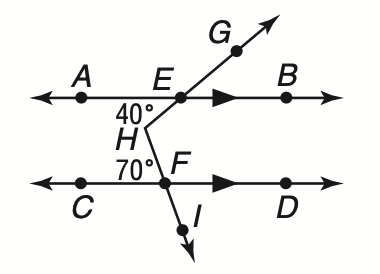Question: What is the measure of \angle G H I?
Choices:
A. 40
B. 70
C. 100
D. 110
Answer with the letter. Answer: D 